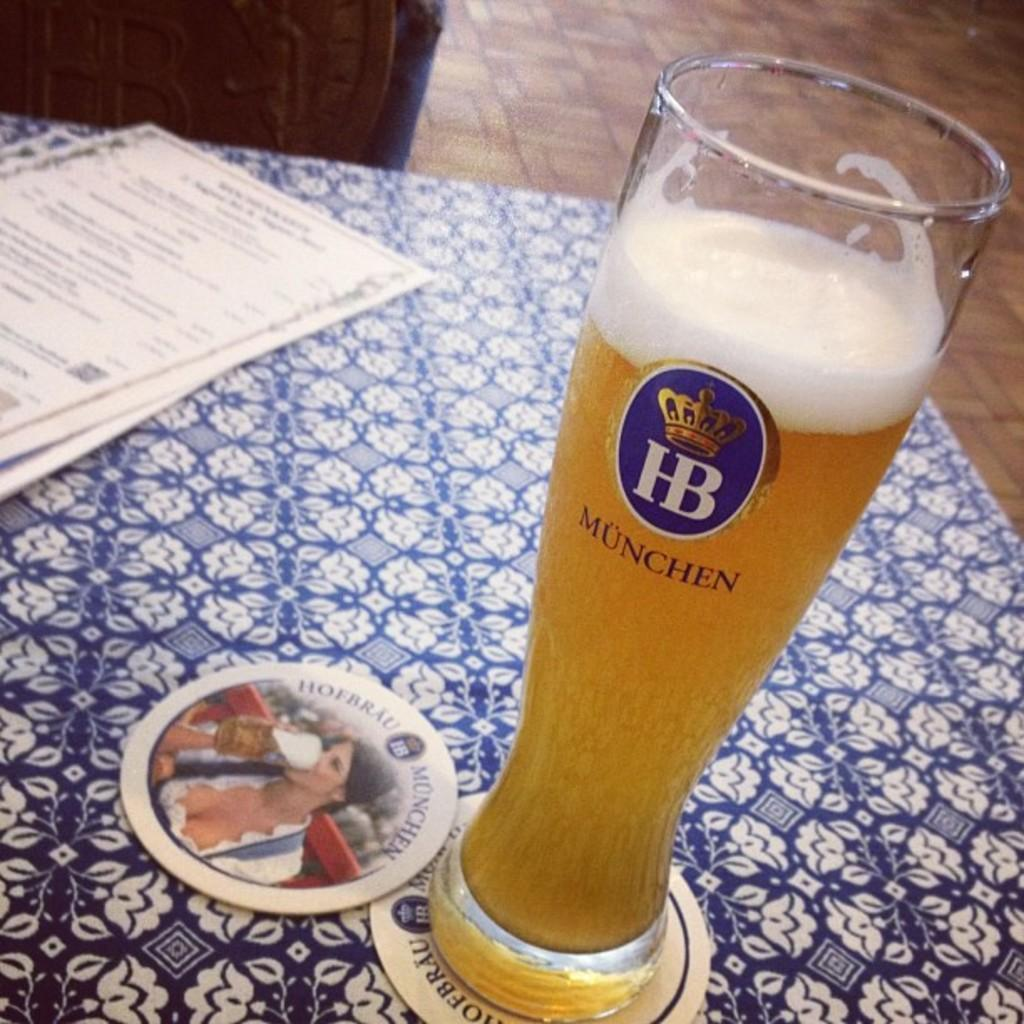What is in the glass that is visible in the image? There is a drink in the glass that is visible in the image. Where is the glass located in the image? The glass is on a table in the image. What else can be seen on the table in the image? There are papers and plates on the table in the image. What object is visible on the floor behind the table in the image? There is an object on the floor behind the table in the image. What tax is being discussed in the image? There is no discussion of taxes in the image; it features a glass filled with a drink, a table with papers and plates, and an object on the floor behind the table. 